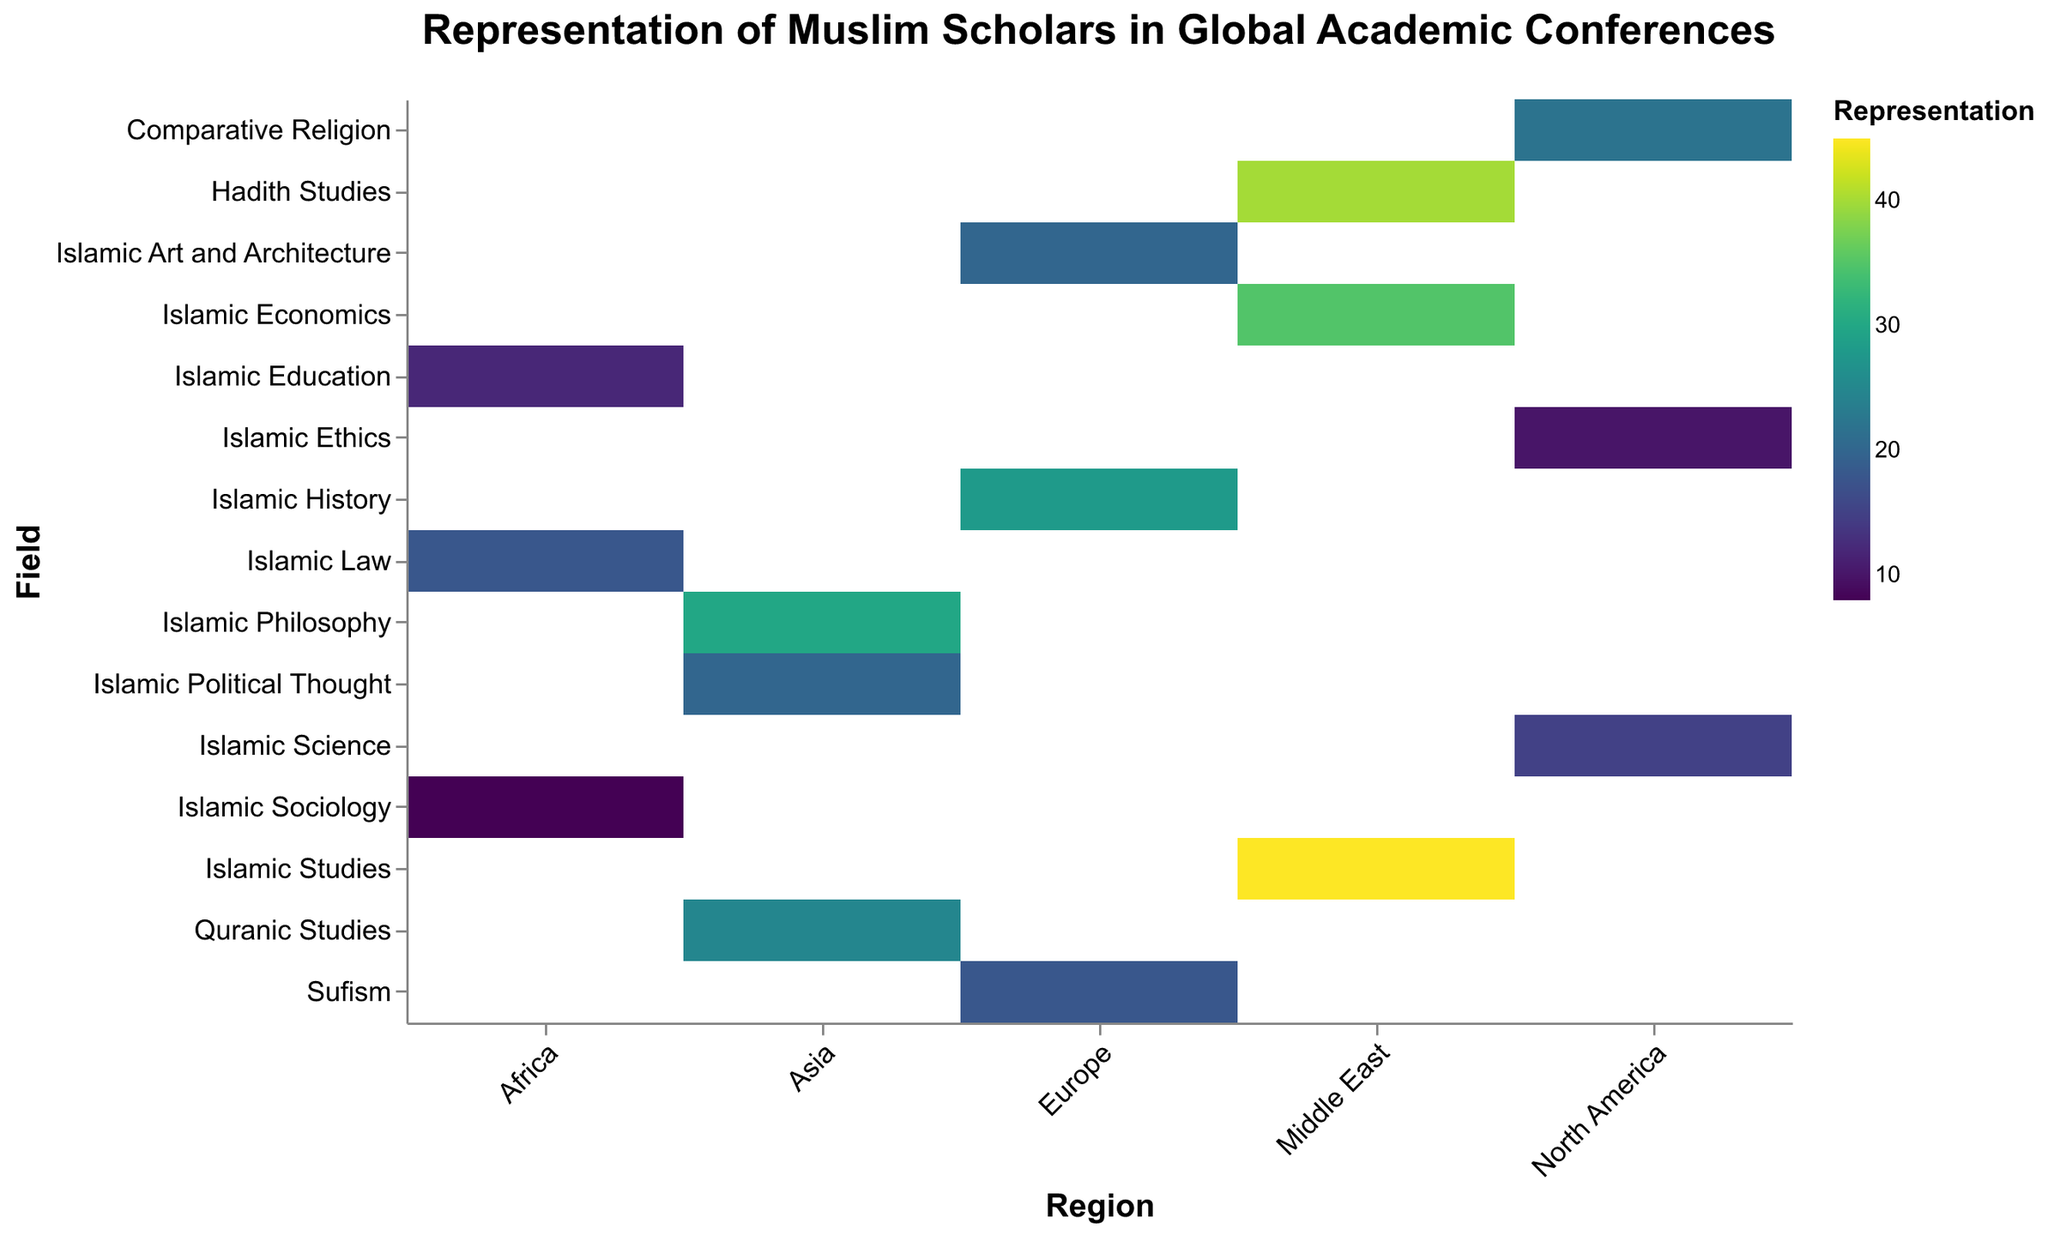What's the title of the figure? The title is prominently displayed at the top center of the figure, indicating the overall theme or subject.
Answer: Representation of Muslim Scholars in Global Academic Conferences What color represents the highest representation, and which data point does it correspond to? By examining the color legend, the darkest color (typically on the viridis scale) represents the highest value. The data point with the darkest color is "Islamic Studies in the Middle East" which has the highest representation value of 45.
Answer: Darkest color, Middle East - Islamic Studies Which region has the highest total representation across all fields? Sum the representation values for each region: Middle East (45+35+40), Europe (28+20+18), North America (22+15+10), Asia (30+25+20), Africa (18+12+8). Middle East has the highest total with 120.
Answer: Middle East Which field of study has the lowest representation, and which region does it come from? By comparing the representation numbers for low values, "Islamic Sociology in Africa" has the lowest value of 8.
Answer: Islamic Sociology in Africa Are there any fields with equal representation across two or more regions? Look for repeated values in the representation column. "Islamic Political Thought in Asia" and "Islamic Art and Architecture in Europe" both have a representation of 20.
Answer: Yes, Islamic Political Thought in Asia and Islamic Art and Architecture in Europe What is the average representation for Islamic studies fields across all regions? Islamic studies fields include: Islamic Studies (45), Islamic History (28), Comparative Religion (22), Islamic Philosophy (30), Islamic Law (18), Islamic Economics (35), Islamic Art and Architecture (20), Islamic Science (15), Quranic Studies (25), Islamic Education (12), Hadith Studies (40), Sufism (18), Islamic Ethics (10), Islamic Political Thought (20), Islamic Sociology (8). Sum is 346, divide by 15 fields; average is 346/15 ≈ 23.07.
Answer: 23.07 Which region has more representation in Islamic Economics: Asia or Middle East? Compare the value of "Islamic Economics" in the Middle East (35) and Asia (not listed, implicitly 0). Therefore, Middle East has more.
Answer: Middle East What is the difference in representation between Islamic Philosophy in Asia and Islamic Law in Africa? Islamic Philosophy in Asia is 30, and Islamic Law in Africa is 18. The difference is 30 - 18 = 12.
Answer: 12 How does the representation of Hadith Studies in the Middle East compare to that of Sufism in Europe? Hadith Studies in the Middle East is 40, while Sufism in Europe is 18. Thus, Hadith Studies has a higher representation.
Answer: Hadith Studies is higher What's the combined representation of all fields in Africa? Add all values for Africa: (18+12+8). The total is 18 + 12 + 8 = 38.
Answer: 38 